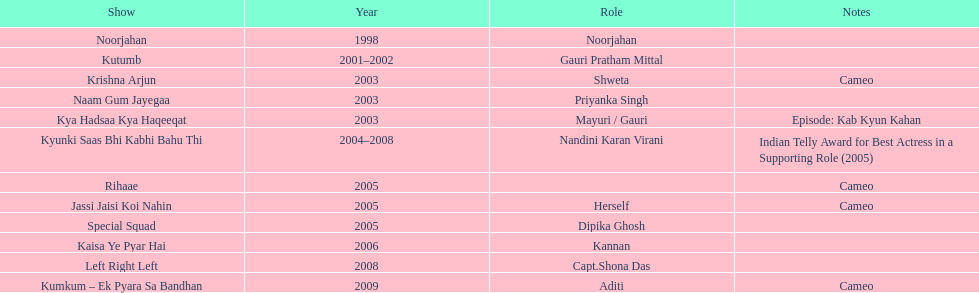How many shows were there in 2005? 3. 